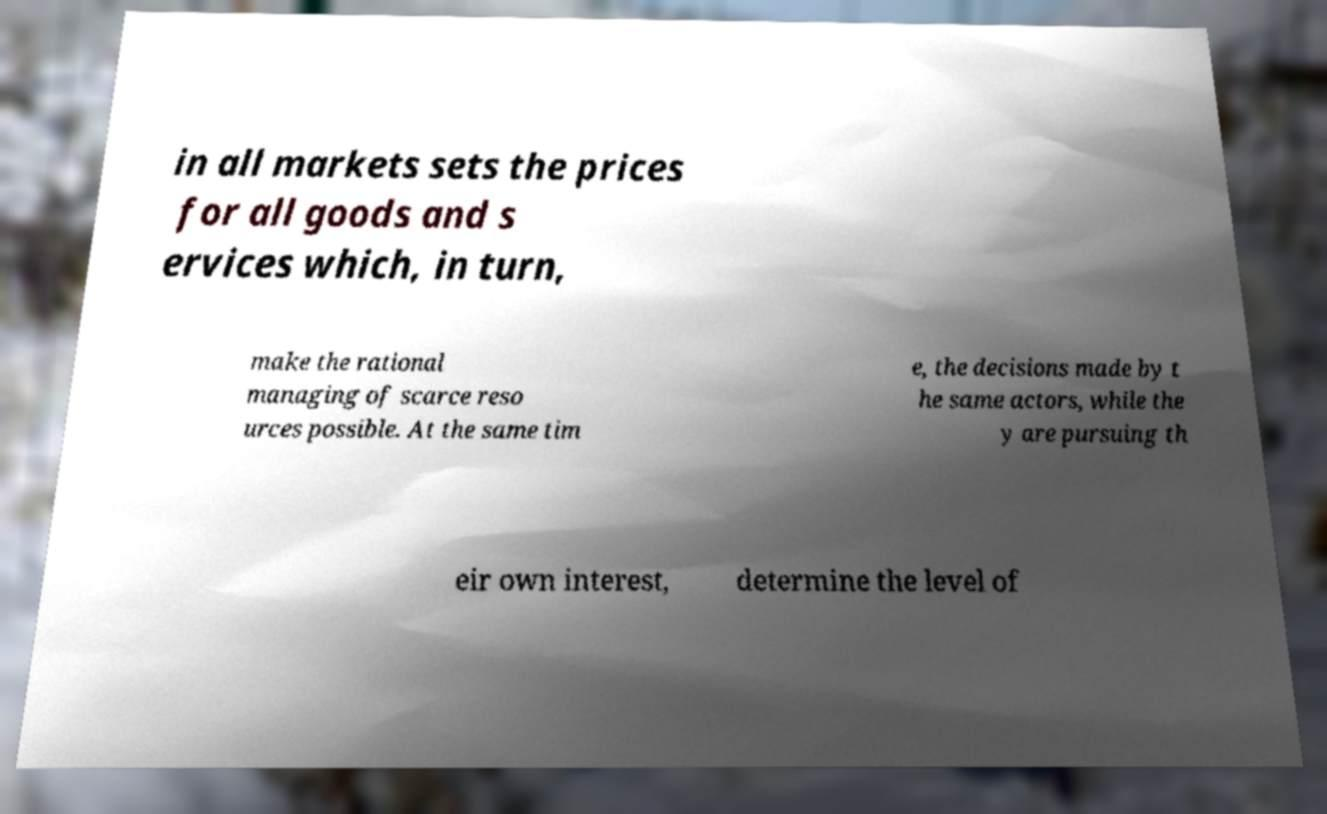Can you read and provide the text displayed in the image?This photo seems to have some interesting text. Can you extract and type it out for me? in all markets sets the prices for all goods and s ervices which, in turn, make the rational managing of scarce reso urces possible. At the same tim e, the decisions made by t he same actors, while the y are pursuing th eir own interest, determine the level of 